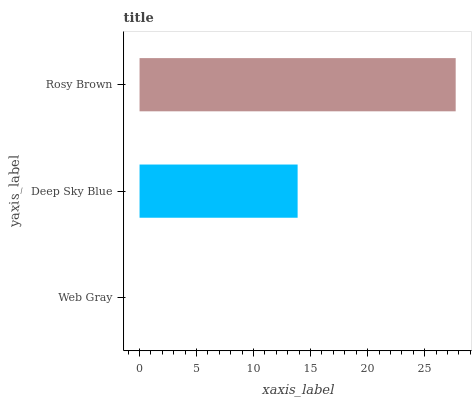Is Web Gray the minimum?
Answer yes or no. Yes. Is Rosy Brown the maximum?
Answer yes or no. Yes. Is Deep Sky Blue the minimum?
Answer yes or no. No. Is Deep Sky Blue the maximum?
Answer yes or no. No. Is Deep Sky Blue greater than Web Gray?
Answer yes or no. Yes. Is Web Gray less than Deep Sky Blue?
Answer yes or no. Yes. Is Web Gray greater than Deep Sky Blue?
Answer yes or no. No. Is Deep Sky Blue less than Web Gray?
Answer yes or no. No. Is Deep Sky Blue the high median?
Answer yes or no. Yes. Is Deep Sky Blue the low median?
Answer yes or no. Yes. Is Web Gray the high median?
Answer yes or no. No. Is Rosy Brown the low median?
Answer yes or no. No. 